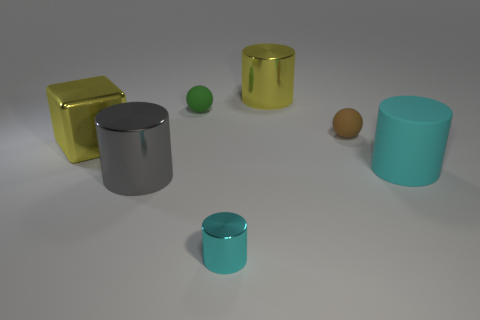Is the shape of the gray metallic thing the same as the metal object that is in front of the gray metal object? Indeed, the shape of the gray metallic cylinder is identical to that of the golden cylinder positioned in front of it. While their sizes and colors differ, the cylindrical form factor is a shared characteristic, giving them a similar geometric structure but with distinct visual appearances due to their differing hues and dimensions. 